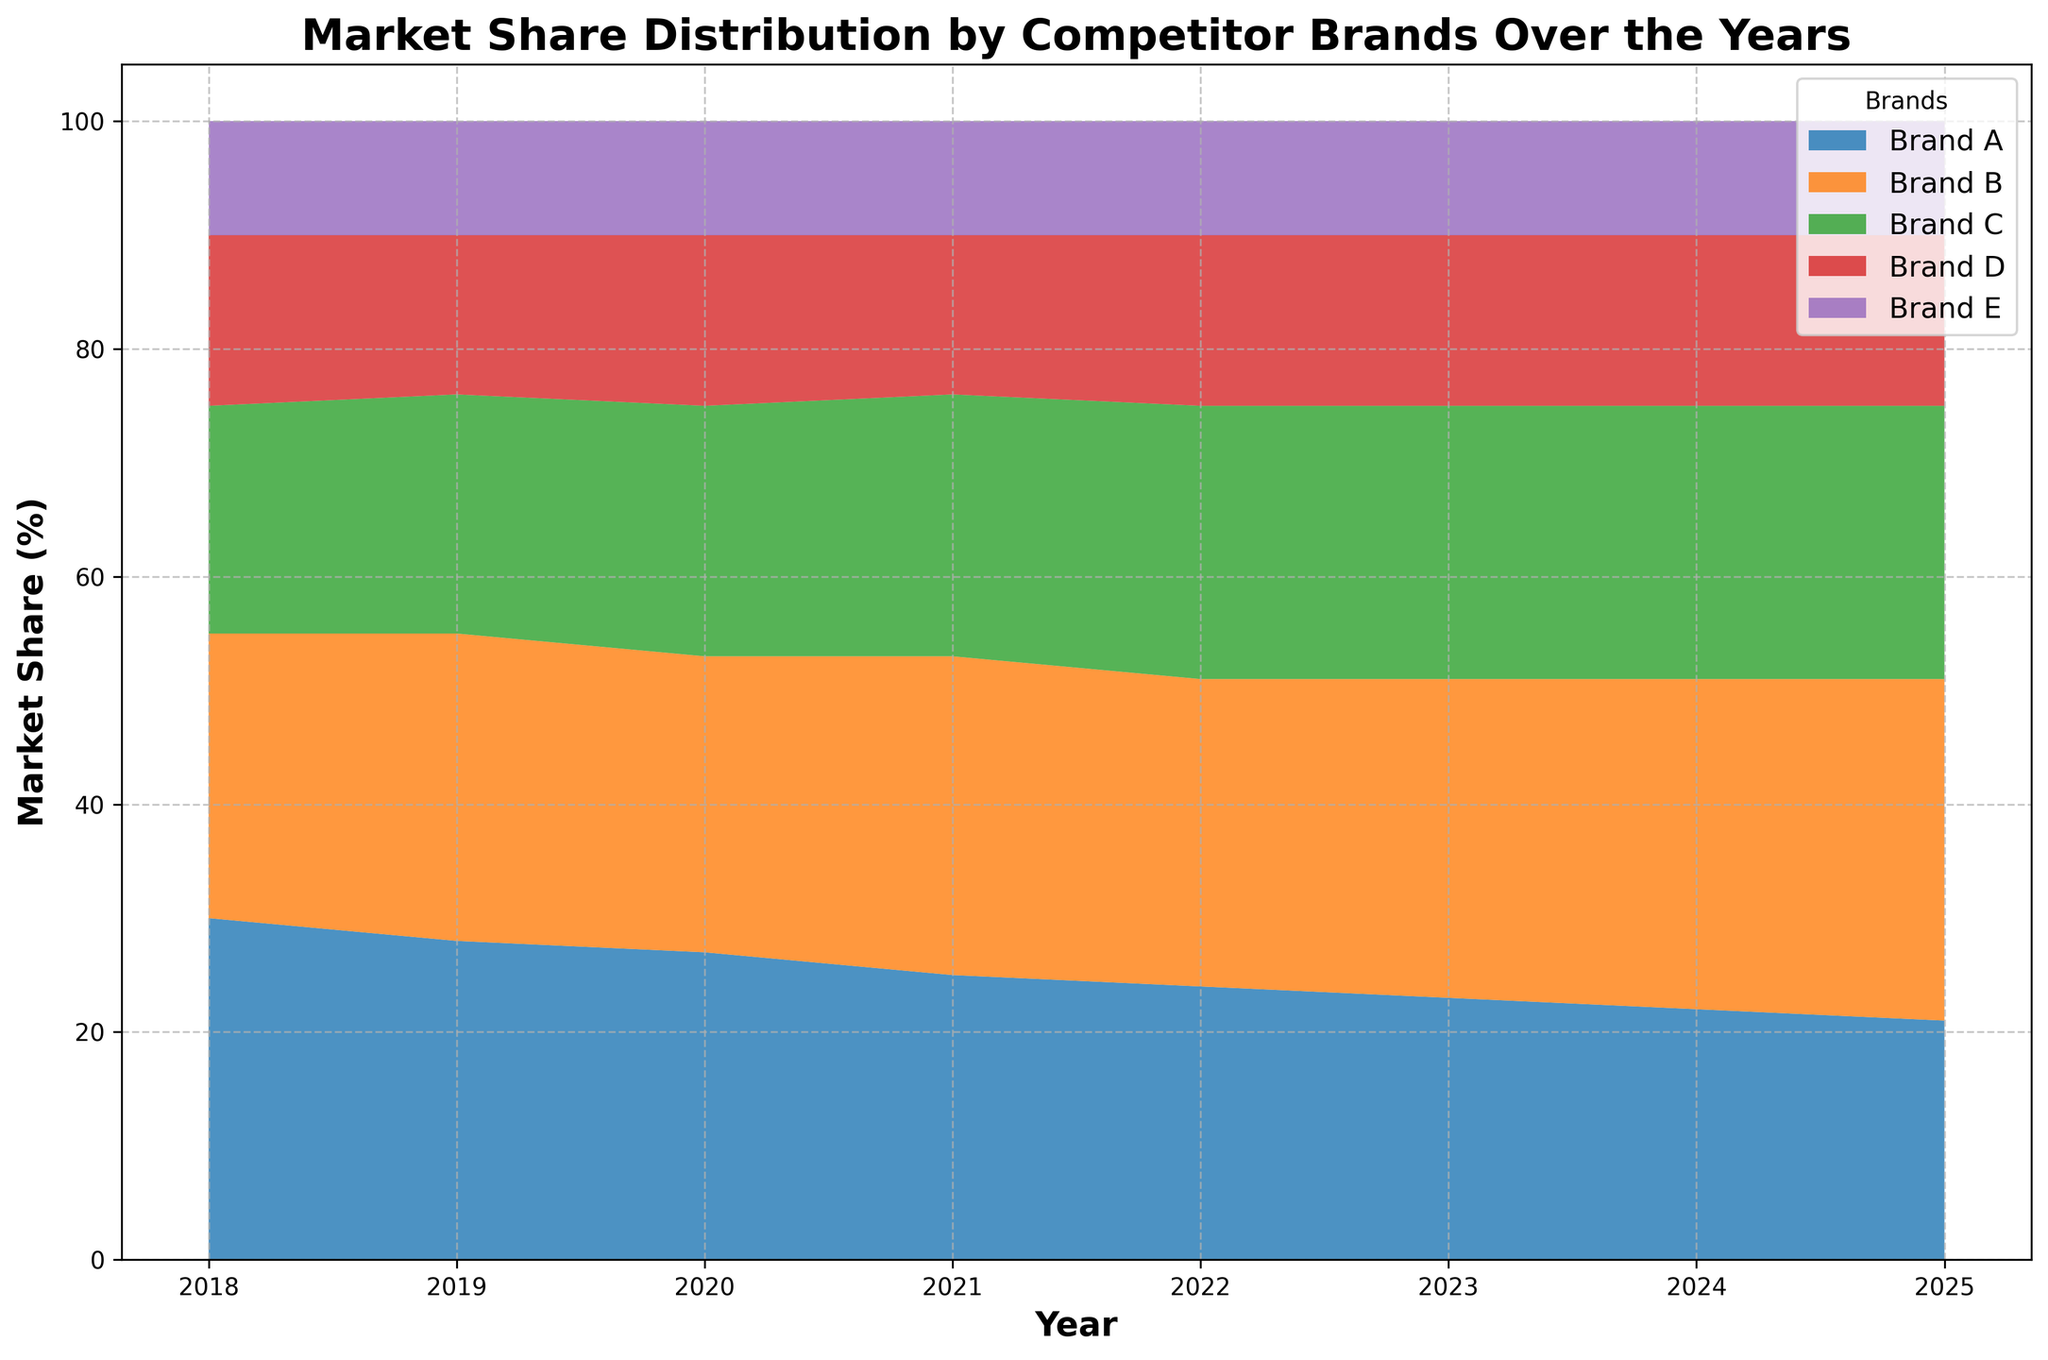Which brand had the highest market share in 2018? The figure shows the market share distribution by year. In 2018, Brand A had the highest area at the top of the stack.
Answer: Brand A How did the market share of Brand C change from 2018 to 2025? Observing the visual representation of the areas for Brand C between 2018 and 2025, the share increased from 20% to 24%.
Answer: Increased by 4% Which year did Brand B have the largest market share? Looking at the chart, the largest area for Brand B is at its peak in 2025.
Answer: 2025 What is the combined market share of Brands D and E in 2024? In 2024, the share of Brand D is 15%, and Brand E is 10%. Summing them up, 15% + 10% = 25%.
Answer: 25% Which brand shows a decreasing trend in market share over the years? By analyzing the chart, only Brand A shows a continuously decreasing trend from 2018 to 2025.
Answer: Brand A In which years do Brands C and D have the same market share percentage? From the chart, Brands C and D have the same market share in 2021 where both are 14%.
Answer: 2021 Compare the market share of Brand A and Brand B in 2020. Which brand had a higher share and by how much? In 2020, Brand A had a share of 27%, while Brand B had 26%. The difference is 27% - 26% = 1%.
Answer: Brand A by 1% What is the average market share of Brand E from 2018 to 2025? Adding Brand E's shares over these years: (10%*8)/8 = 10%. So the average is 10%.
Answer: 10% Which brands had the same market share in 2023 and what was the percentage? In 2023, Brands C and E both had a market share of 24%.
Answer: Brand C and Brand E at 24% Identify the years where Brand D holds the same market share percentage. By examining the chart, Brand D maintains a consistent market share of 15% from 2018 to 2025.
Answer: 2018-2025 